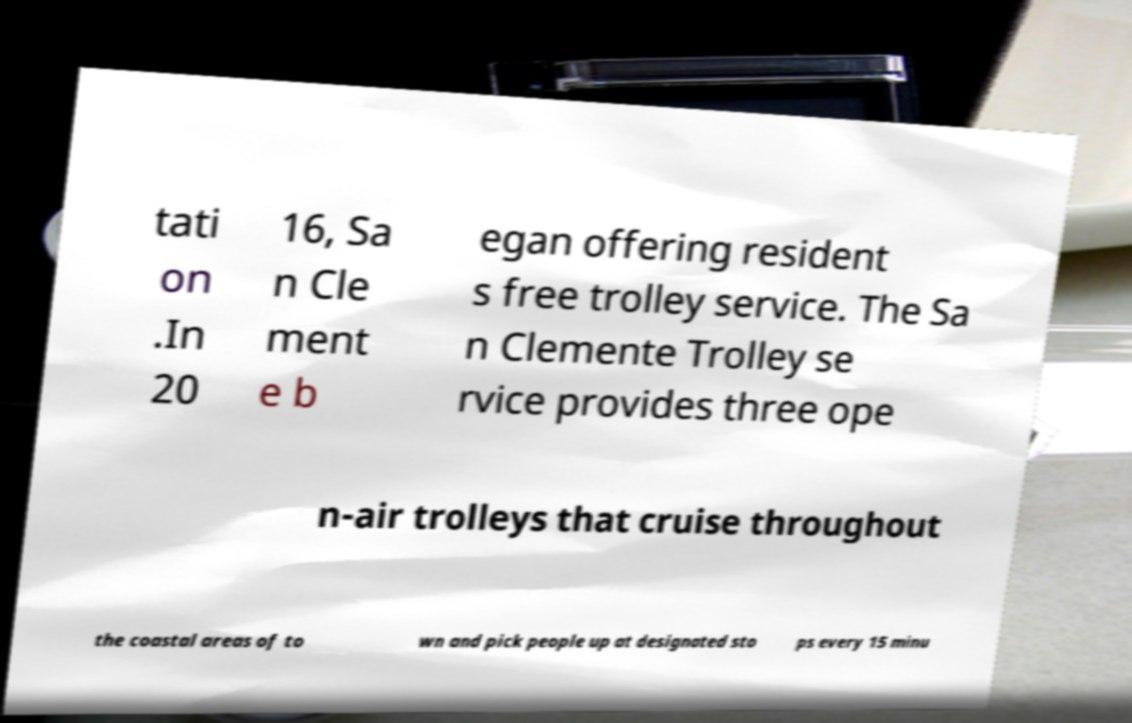What messages or text are displayed in this image? I need them in a readable, typed format. tati on .In 20 16, Sa n Cle ment e b egan offering resident s free trolley service. The Sa n Clemente Trolley se rvice provides three ope n-air trolleys that cruise throughout the coastal areas of to wn and pick people up at designated sto ps every 15 minu 